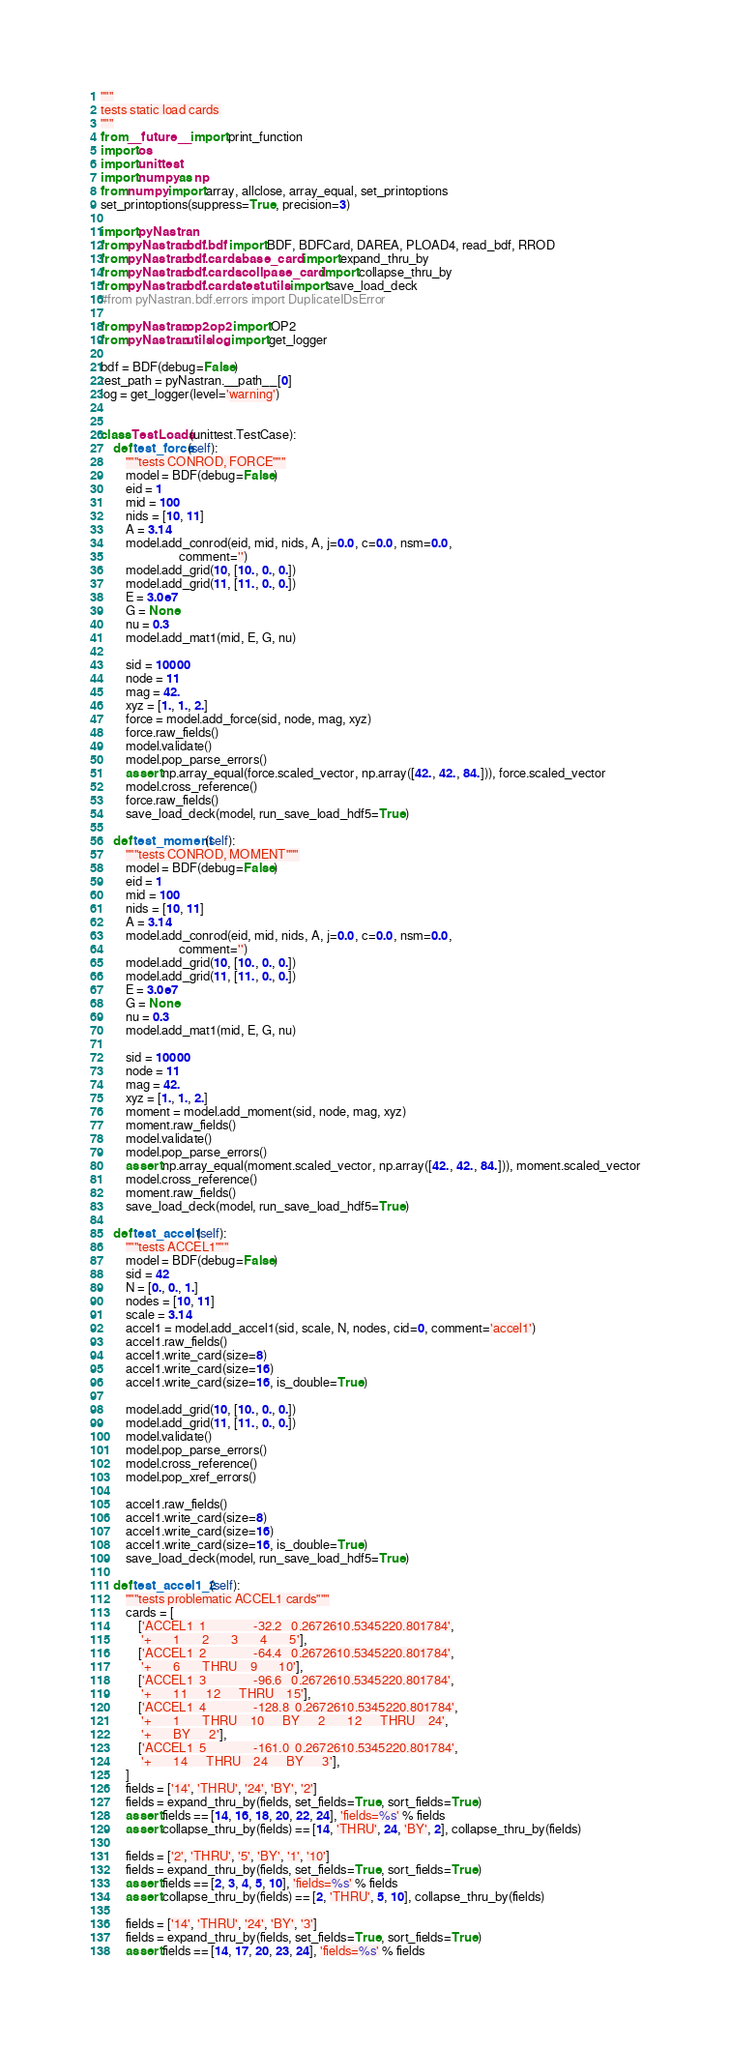<code> <loc_0><loc_0><loc_500><loc_500><_Python_>"""
tests static load cards
"""
from __future__ import print_function
import os
import unittest
import numpy as np
from numpy import array, allclose, array_equal, set_printoptions
set_printoptions(suppress=True, precision=3)

import pyNastran
from pyNastran.bdf.bdf import BDF, BDFCard, DAREA, PLOAD4, read_bdf, RROD
from pyNastran.bdf.cards.base_card import expand_thru_by
from pyNastran.bdf.cards.collpase_card import collapse_thru_by
from pyNastran.bdf.cards.test.utils import save_load_deck
#from pyNastran.bdf.errors import DuplicateIDsError

from pyNastran.op2.op2 import OP2
from pyNastran.utils.log import get_logger

bdf = BDF(debug=False)
test_path = pyNastran.__path__[0]
log = get_logger(level='warning')


class TestLoads(unittest.TestCase):
    def test_force(self):
        """tests CONROD, FORCE"""
        model = BDF(debug=False)
        eid = 1
        mid = 100
        nids = [10, 11]
        A = 3.14
        model.add_conrod(eid, mid, nids, A, j=0.0, c=0.0, nsm=0.0,
                         comment='')
        model.add_grid(10, [10., 0., 0.])
        model.add_grid(11, [11., 0., 0.])
        E = 3.0e7
        G = None
        nu = 0.3
        model.add_mat1(mid, E, G, nu)

        sid = 10000
        node = 11
        mag = 42.
        xyz = [1., 1., 2.]
        force = model.add_force(sid, node, mag, xyz)
        force.raw_fields()
        model.validate()
        model.pop_parse_errors()
        assert np.array_equal(force.scaled_vector, np.array([42., 42., 84.])), force.scaled_vector
        model.cross_reference()
        force.raw_fields()
        save_load_deck(model, run_save_load_hdf5=True)

    def test_moment(self):
        """tests CONROD, MOMENT"""
        model = BDF(debug=False)
        eid = 1
        mid = 100
        nids = [10, 11]
        A = 3.14
        model.add_conrod(eid, mid, nids, A, j=0.0, c=0.0, nsm=0.0,
                         comment='')
        model.add_grid(10, [10., 0., 0.])
        model.add_grid(11, [11., 0., 0.])
        E = 3.0e7
        G = None
        nu = 0.3
        model.add_mat1(mid, E, G, nu)

        sid = 10000
        node = 11
        mag = 42.
        xyz = [1., 1., 2.]
        moment = model.add_moment(sid, node, mag, xyz)
        moment.raw_fields()
        model.validate()
        model.pop_parse_errors()
        assert np.array_equal(moment.scaled_vector, np.array([42., 42., 84.])), moment.scaled_vector
        model.cross_reference()
        moment.raw_fields()
        save_load_deck(model, run_save_load_hdf5=True)

    def test_accel1(self):
        """tests ACCEL1"""
        model = BDF(debug=False)
        sid = 42
        N = [0., 0., 1.]
        nodes = [10, 11]
        scale = 3.14
        accel1 = model.add_accel1(sid, scale, N, nodes, cid=0, comment='accel1')
        accel1.raw_fields()
        accel1.write_card(size=8)
        accel1.write_card(size=16)
        accel1.write_card(size=16, is_double=True)

        model.add_grid(10, [10., 0., 0.])
        model.add_grid(11, [11., 0., 0.])
        model.validate()
        model.pop_parse_errors()
        model.cross_reference()
        model.pop_xref_errors()

        accel1.raw_fields()
        accel1.write_card(size=8)
        accel1.write_card(size=16)
        accel1.write_card(size=16, is_double=True)
        save_load_deck(model, run_save_load_hdf5=True)

    def test_accel1_2(self):
        """tests problematic ACCEL1 cards"""
        cards = [
            ['ACCEL1  1               -32.2   0.2672610.5345220.801784',
             '+       1       2       3       4       5'],
            ['ACCEL1  2               -64.4   0.2672610.5345220.801784',
             '+       6       THRU    9       10'],
            ['ACCEL1  3               -96.6   0.2672610.5345220.801784',
             '+       11      12      THRU    15'],
            ['ACCEL1  4               -128.8  0.2672610.5345220.801784',
             '+       1       THRU    10      BY      2       12      THRU    24',
             '+       BY      2'],
            ['ACCEL1  5               -161.0  0.2672610.5345220.801784',
             '+       14      THRU    24      BY      3'],
        ]
        fields = ['14', 'THRU', '24', 'BY', '2']
        fields = expand_thru_by(fields, set_fields=True, sort_fields=True)
        assert fields == [14, 16, 18, 20, 22, 24], 'fields=%s' % fields
        assert collapse_thru_by(fields) == [14, 'THRU', 24, 'BY', 2], collapse_thru_by(fields)

        fields = ['2', 'THRU', '5', 'BY', '1', '10']
        fields = expand_thru_by(fields, set_fields=True, sort_fields=True)
        assert fields == [2, 3, 4, 5, 10], 'fields=%s' % fields
        assert collapse_thru_by(fields) == [2, 'THRU', 5, 10], collapse_thru_by(fields)

        fields = ['14', 'THRU', '24', 'BY', '3']
        fields = expand_thru_by(fields, set_fields=True, sort_fields=True)
        assert fields == [14, 17, 20, 23, 24], 'fields=%s' % fields</code> 